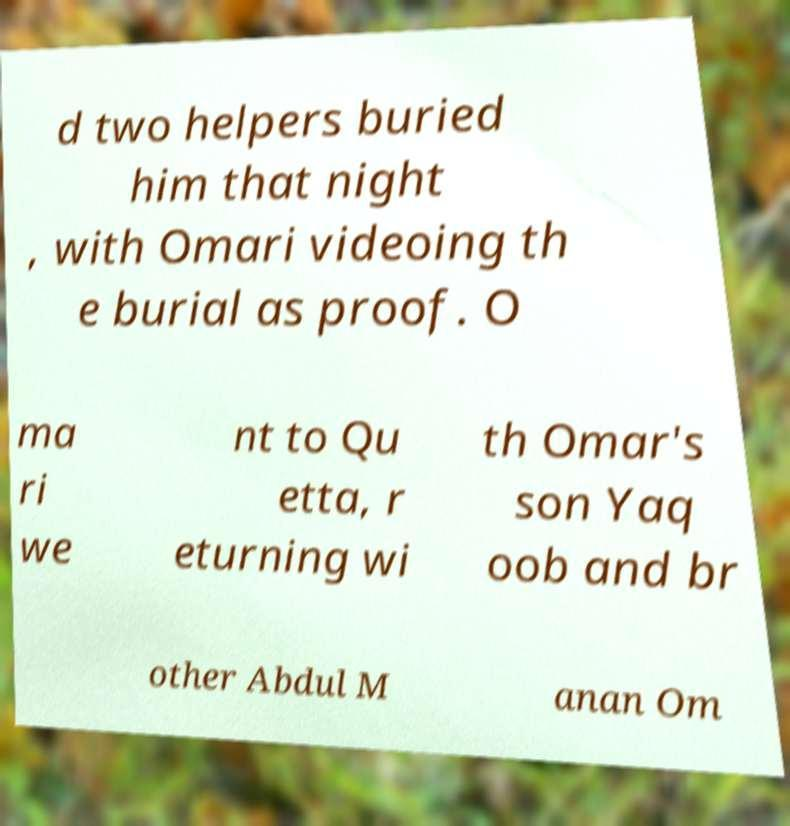Could you extract and type out the text from this image? d two helpers buried him that night , with Omari videoing th e burial as proof. O ma ri we nt to Qu etta, r eturning wi th Omar's son Yaq oob and br other Abdul M anan Om 